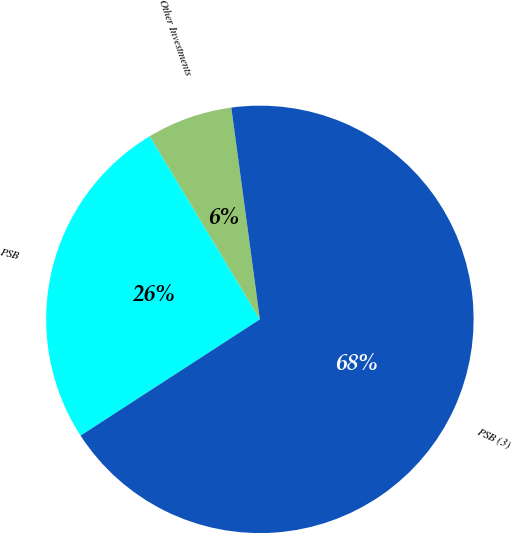Convert chart to OTSL. <chart><loc_0><loc_0><loc_500><loc_500><pie_chart><fcel>PSB<fcel>Other Investments<fcel>PSB (3)<nl><fcel>25.54%<fcel>6.48%<fcel>67.98%<nl></chart> 